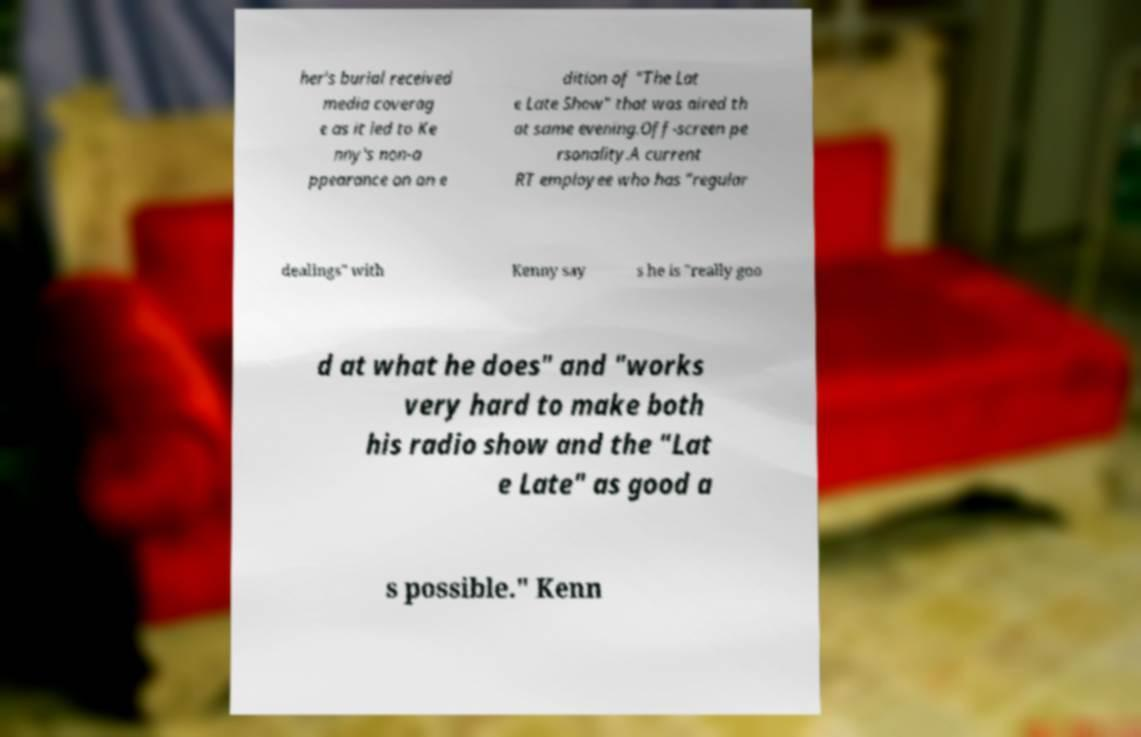Could you assist in decoding the text presented in this image and type it out clearly? her's burial received media coverag e as it led to Ke nny's non-a ppearance on an e dition of "The Lat e Late Show" that was aired th at same evening.Off-screen pe rsonality.A current RT employee who has "regular dealings" with Kenny say s he is "really goo d at what he does" and "works very hard to make both his radio show and the "Lat e Late" as good a s possible." Kenn 